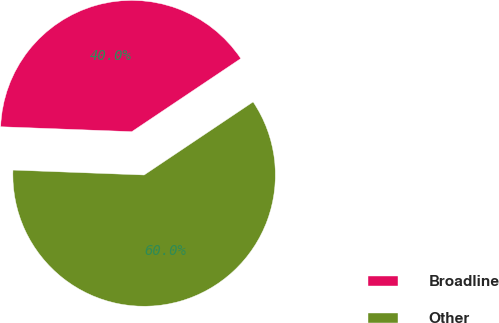Convert chart to OTSL. <chart><loc_0><loc_0><loc_500><loc_500><pie_chart><fcel>Broadline<fcel>Other<nl><fcel>40.0%<fcel>60.0%<nl></chart> 